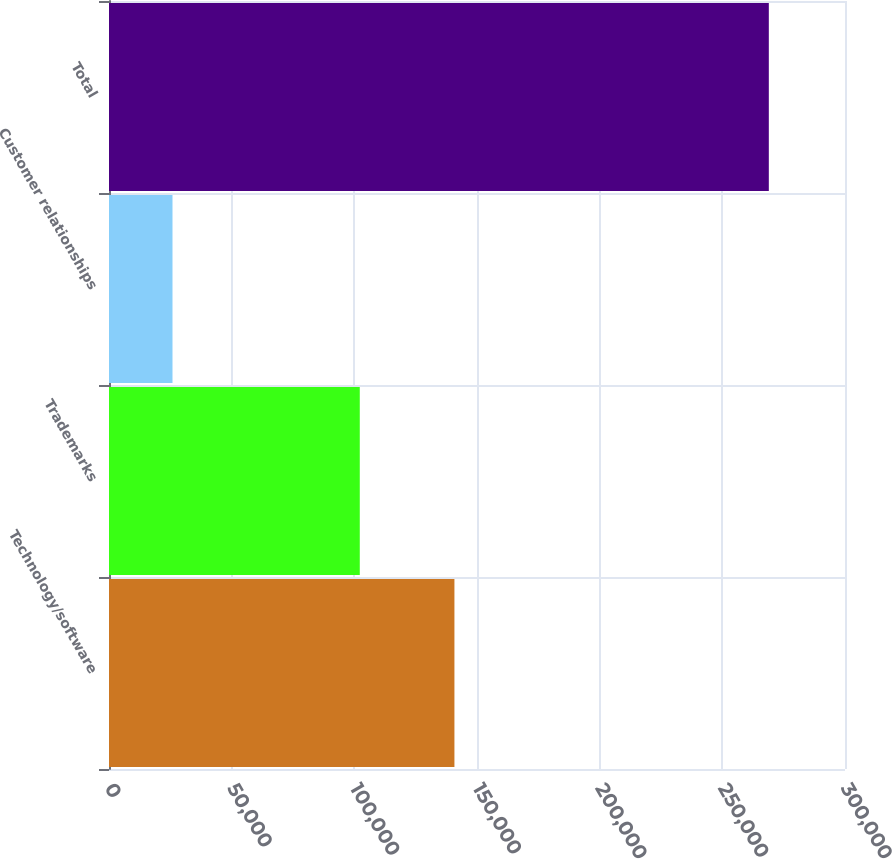<chart> <loc_0><loc_0><loc_500><loc_500><bar_chart><fcel>Technology/software<fcel>Trademarks<fcel>Customer relationships<fcel>Total<nl><fcel>140800<fcel>102220<fcel>25880<fcel>268950<nl></chart> 